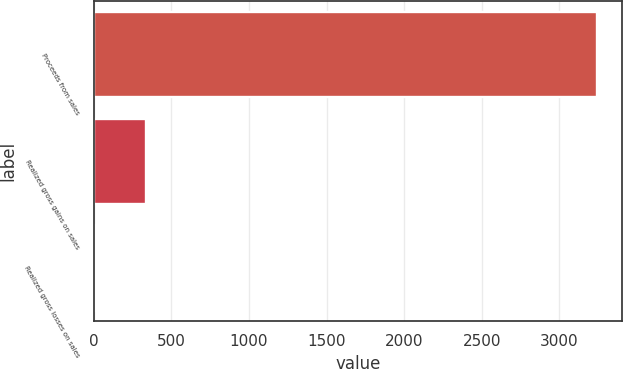<chart> <loc_0><loc_0><loc_500><loc_500><bar_chart><fcel>Proceeds from sales<fcel>Realized gross gains on sales<fcel>Realized gross losses on sales<nl><fcel>3240.5<fcel>337.19<fcel>14.6<nl></chart> 